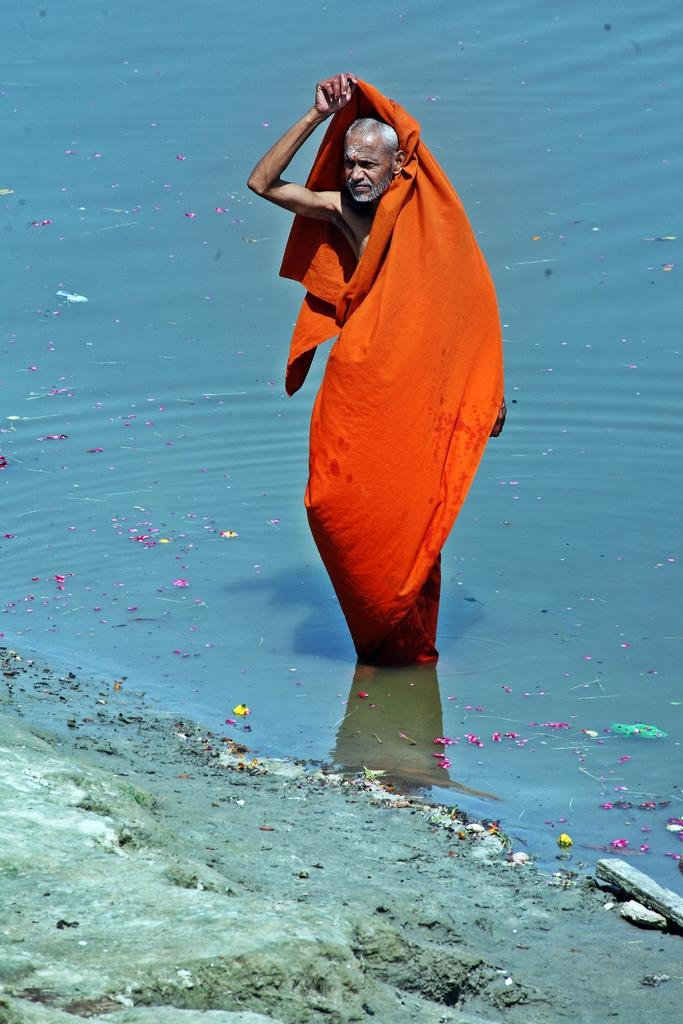Who or what is present in the image? There is a person in the image. What is the person wearing? The person is wearing an orange cloth. Where is the person located in the image? The person is standing in the water. What can be seen in front of the person? There is a rock in front of the person. What type of trousers is the person wearing in the image? The provided facts do not mention any trousers; the person is wearing an orange cloth. Is the person using a notebook in the image? There is no mention of a notebook in the image; the person is standing in the water with a rock in front of them. 